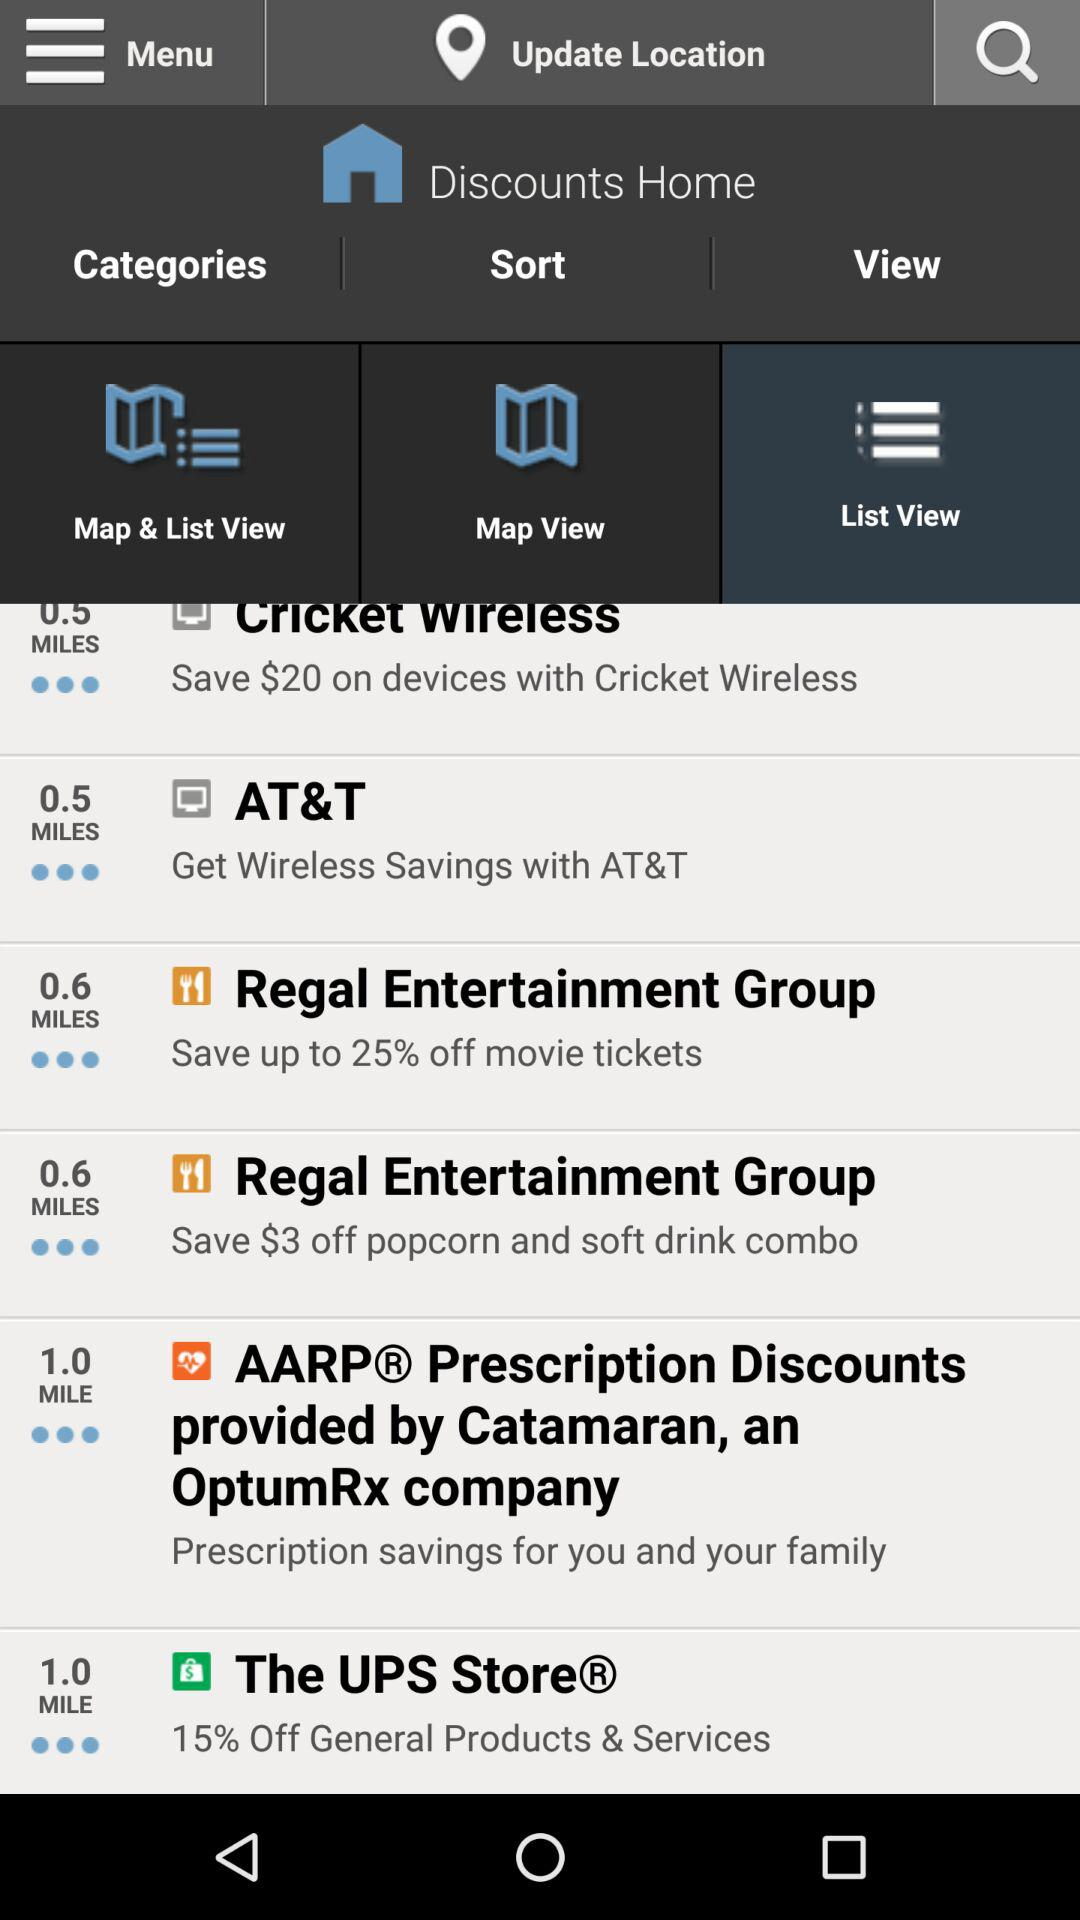How far is "The UPS Store"? "The UPS Store" is 1 mile away. 